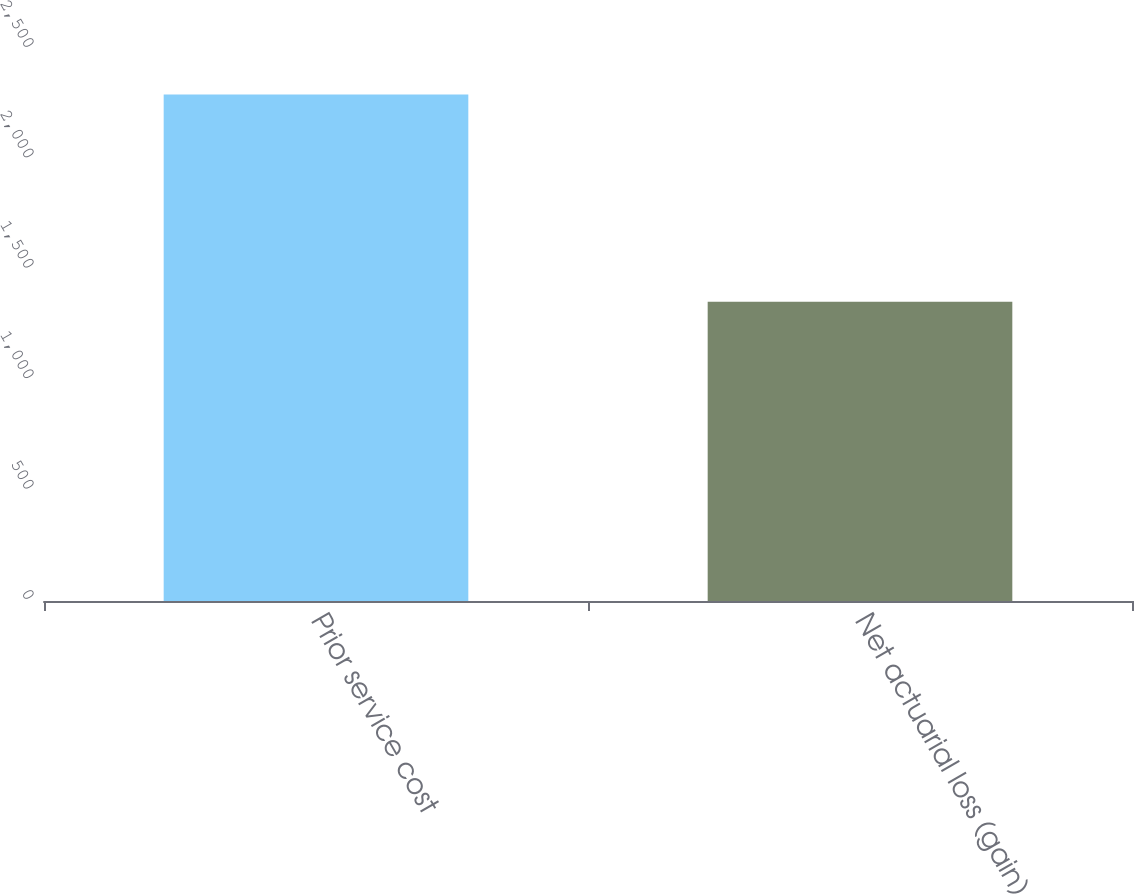<chart> <loc_0><loc_0><loc_500><loc_500><bar_chart><fcel>Prior service cost<fcel>Net actuarial loss (gain)<nl><fcel>2294<fcel>1355<nl></chart> 